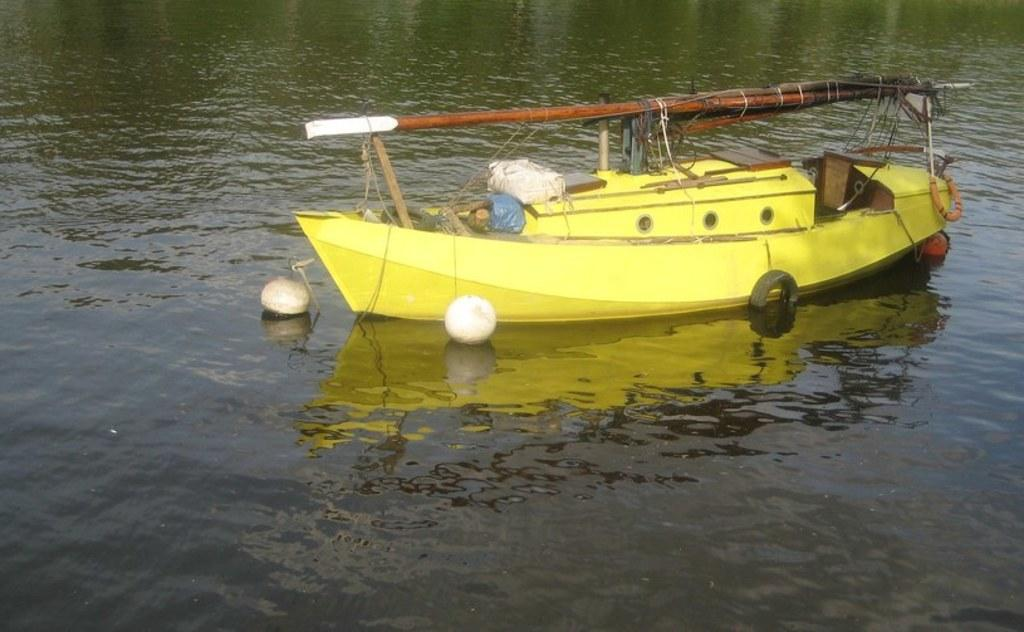What color is the boat in the image? The boat in the image is yellow. Where is the boat located? The boat is on the water. What objects are near the boat? There are two tubes and two white-colored things near the boat. What type of beef is being cooked on the boat in the image? There is no beef or any cooking activity present in the image; it only features a yellow boat on the water with two tubes and two white-colored things nearby. 